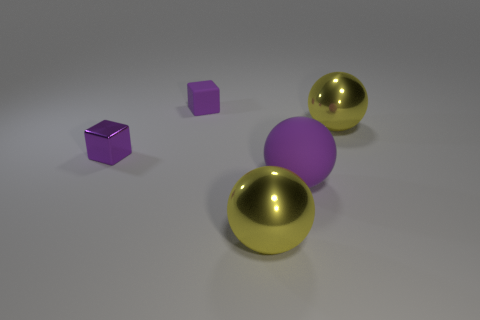What materials appear to be represented in the objects shown in the image? The materials depicted in the image include a metallic texture on both the small purple cube and the two shiny spheres, suggesting a polished metal surface that reflects light. In contrast, the large purple ball has a matte finish, which diffuses light and gives it a non-reflective appearance. How does the lighting in the image affect the appearance of these objects? The lighting in the image is set up in a way to accentuate the properties of the materials. The reflective spheres capture and mirror the light, emphasizing their glossiness, while the matte ball absorbs the light, displaying subtle shadows that highlight its texture. The lighting also creates soft shadows on the ground, adding to the three-dimensional feel of the scene. 